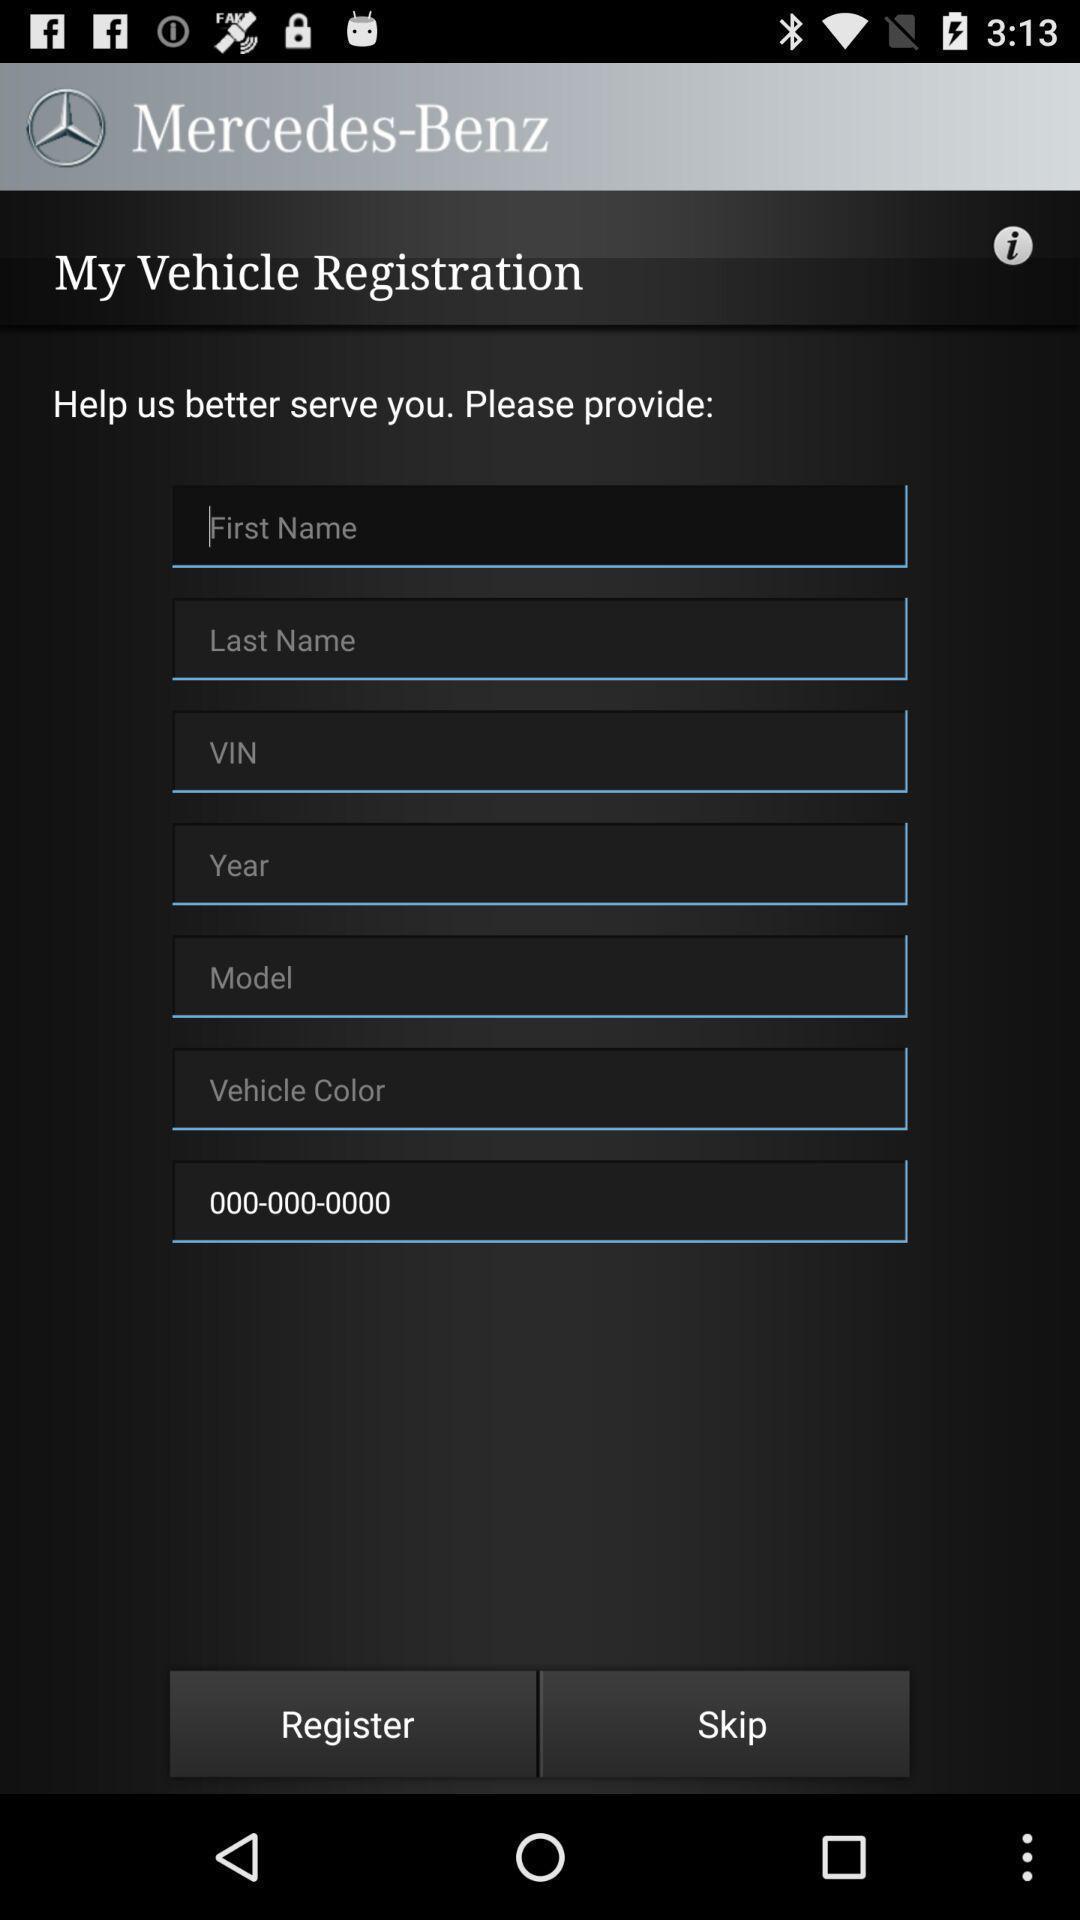Give me a narrative description of this picture. Vehicle registration page showing in application. 